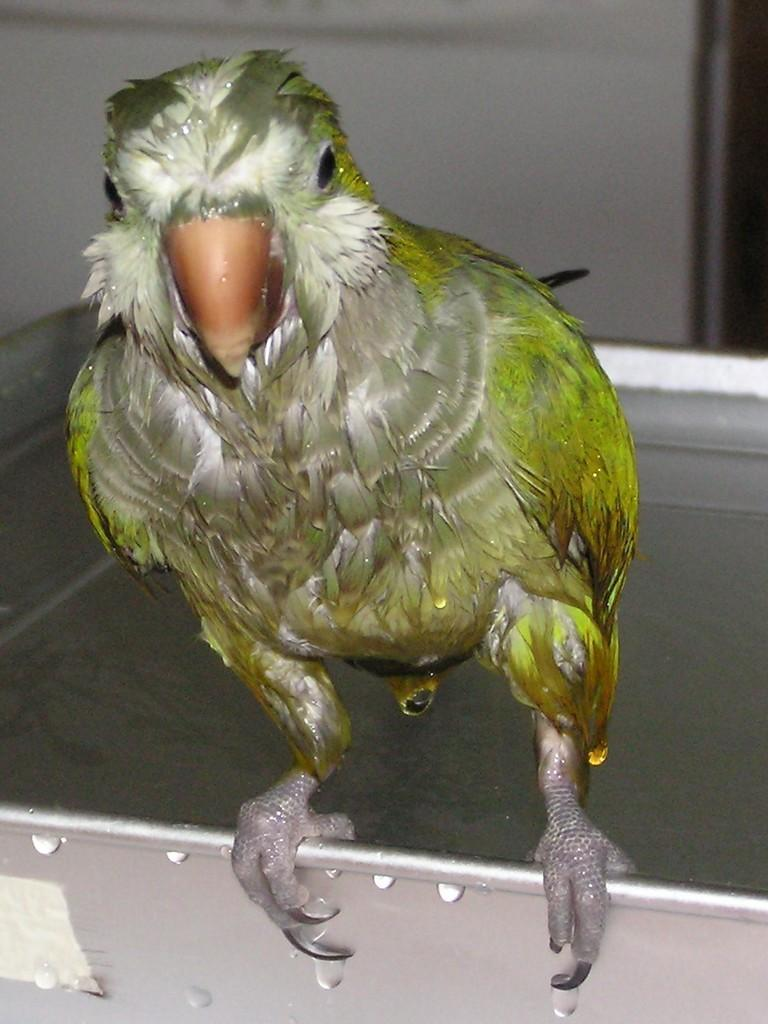Where was the image taken? The image was taken inside a room. What can be seen in the foreground of the image? There is a bird, possibly a parrot, in the foreground of the image. What is the bird standing on? The bird is standing on an object. What can be seen in the background of the image? There is a wall visible in the image. What else is present in the room besides the bird? There are other items in the room. What is the bird's tendency to fly in the image? The image does not show the bird flying, so we cannot determine its tendency to fly. --- Facts: 1. There is a person sitting on a chair in the image. 2. The person is holding a book. 3. The book has a blue cover. 4. There is a table next to the chair. 5. The table has a lamp on it. Absurd Topics: ocean, elephant, dance Conversation: What is the person in the image doing? The person is sitting on a chair in the image. What is the person holding? The person is holding a book. What color is the book's cover? The book has a blue cover. What is located next to the chair? There is a table next to the chair. What is on the table? The table has a lamp on it. Reasoning: Let's think step by step in order to produce the conversation. We start by identifying the main subject in the image, which is the person sitting on a chair. Then, we describe what the person is holding, which is a book. We mention the color of the book's cover to provide additional detail. Next, we acknowledge the presence of a table next to the chair. Finally, we describe the object on the table, which is a lamp. Absurd Question/Answer: Can you see the ocean in the image? No, the image does not show the ocean. Is there an elephant in the room with the person? No, there is no elephant present in the image. 